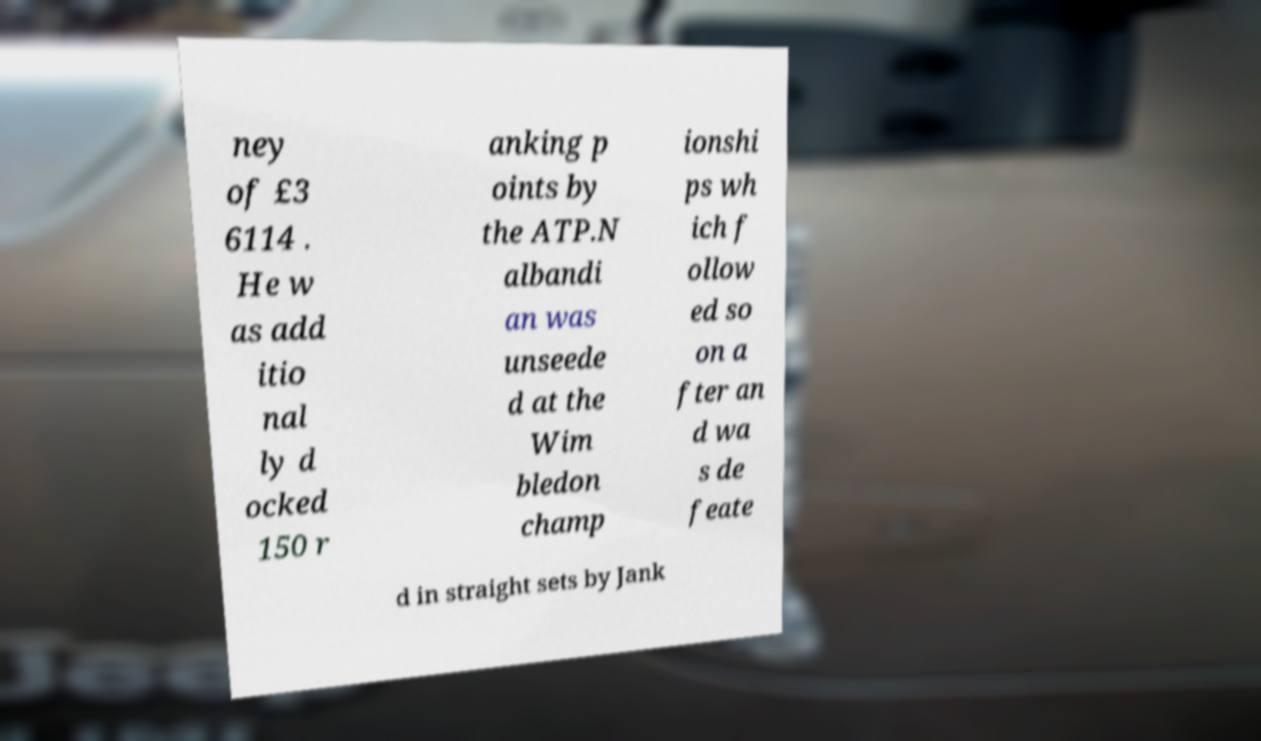Please identify and transcribe the text found in this image. ney of £3 6114 . He w as add itio nal ly d ocked 150 r anking p oints by the ATP.N albandi an was unseede d at the Wim bledon champ ionshi ps wh ich f ollow ed so on a fter an d wa s de feate d in straight sets by Jank 